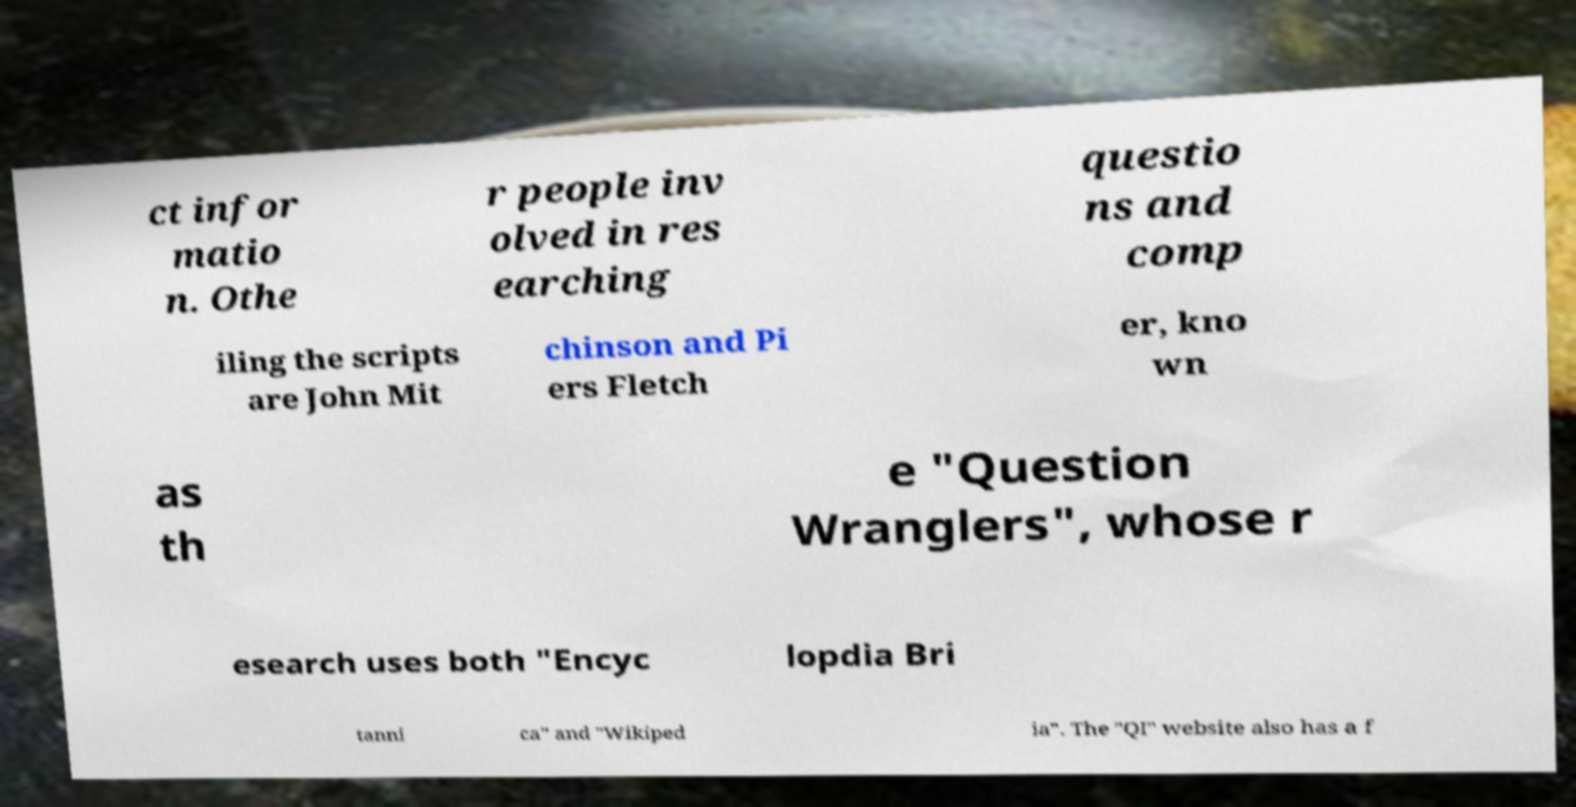For documentation purposes, I need the text within this image transcribed. Could you provide that? ct infor matio n. Othe r people inv olved in res earching questio ns and comp iling the scripts are John Mit chinson and Pi ers Fletch er, kno wn as th e "Question Wranglers", whose r esearch uses both "Encyc lopdia Bri tanni ca" and "Wikiped ia". The "QI" website also has a f 